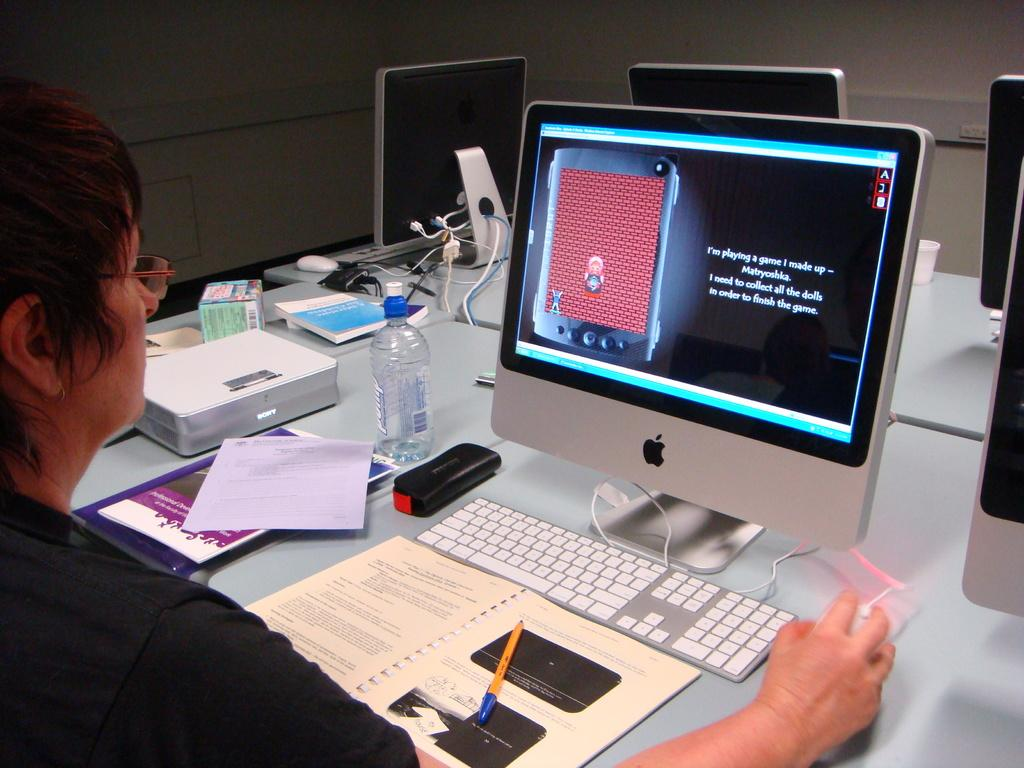<image>
Describe the image concisely. A woman in a corporate setting plays a game of Matryoshka. 